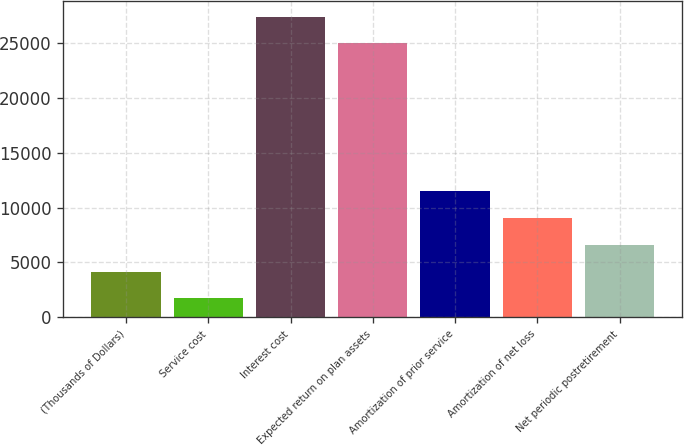Convert chart to OTSL. <chart><loc_0><loc_0><loc_500><loc_500><bar_chart><fcel>(Thousands of Dollars)<fcel>Service cost<fcel>Interest cost<fcel>Expected return on plan assets<fcel>Amortization of prior service<fcel>Amortization of net loss<fcel>Net periodic postretirement<nl><fcel>4165<fcel>1727<fcel>27433<fcel>24995<fcel>11479<fcel>9041<fcel>6603<nl></chart> 